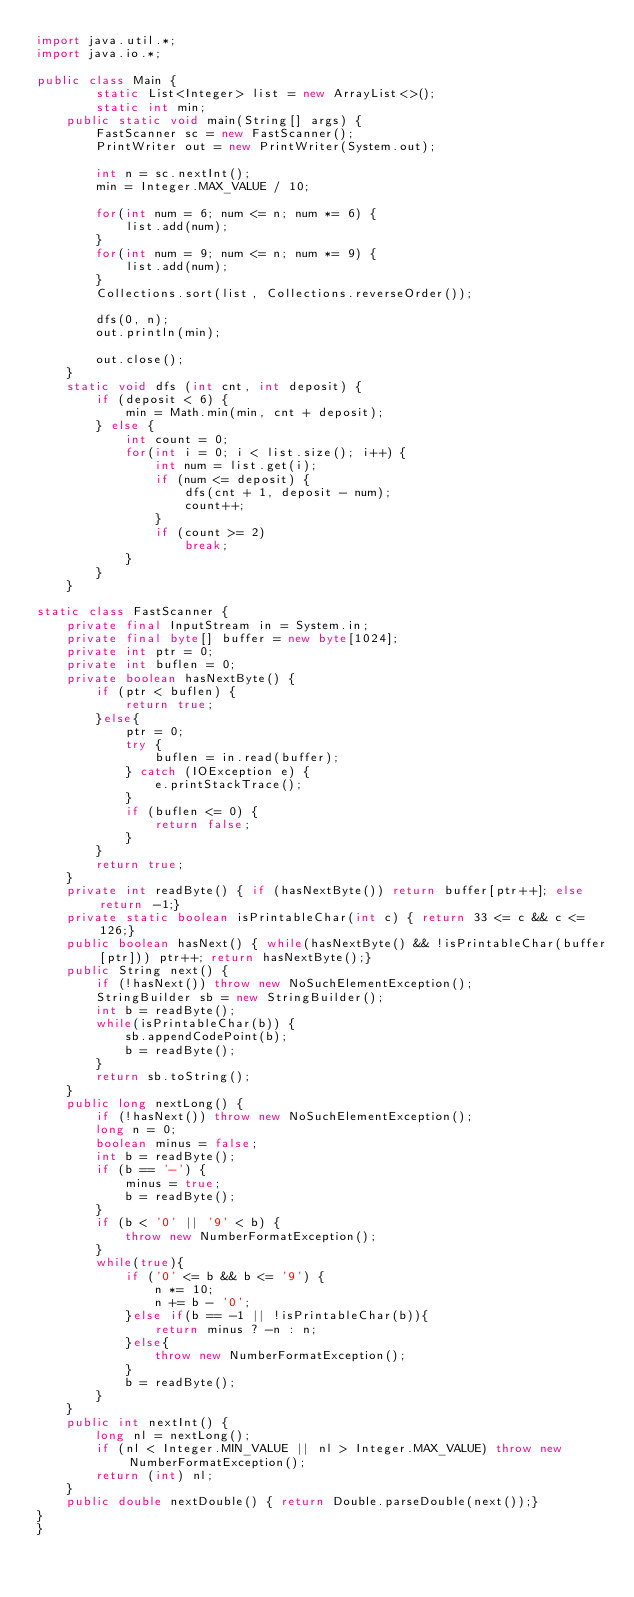<code> <loc_0><loc_0><loc_500><loc_500><_Java_>import java.util.*;
import java.io.*;

public class Main {
		static List<Integer> list = new ArrayList<>();
		static int min;
	public static void main(String[] args) {
		FastScanner sc = new FastScanner();
		PrintWriter out = new PrintWriter(System.out);
		
		int n = sc.nextInt();
		min = Integer.MAX_VALUE / 10;

		for(int num = 6; num <= n; num *= 6) {
			list.add(num);
		}
		for(int num = 9; num <= n; num *= 9) {
			list.add(num);
		}
		Collections.sort(list, Collections.reverseOrder());
		
		dfs(0, n);
		out.println(min);
				
		out.close();
	} 
	static void dfs (int cnt, int deposit) {
		if (deposit < 6) {
			min = Math.min(min, cnt + deposit);
		} else {
			int count = 0;
			for(int i = 0; i < list.size(); i++) {
				int num = list.get(i);
				if (num <= deposit) {
					dfs(cnt + 1, deposit - num);
					count++;
				}
				if (count >= 2)
					break;
			} 
		}
	}

static class FastScanner {
    private final InputStream in = System.in;
    private final byte[] buffer = new byte[1024];
    private int ptr = 0;
    private int buflen = 0;
    private boolean hasNextByte() {
        if (ptr < buflen) {
            return true;
        }else{
            ptr = 0;
            try {
                buflen = in.read(buffer);
            } catch (IOException e) {
                e.printStackTrace();
            }
            if (buflen <= 0) {
                return false;
            }
        }
        return true;
    }
    private int readByte() { if (hasNextByte()) return buffer[ptr++]; else return -1;}
    private static boolean isPrintableChar(int c) { return 33 <= c && c <= 126;}
    public boolean hasNext() { while(hasNextByte() && !isPrintableChar(buffer[ptr])) ptr++; return hasNextByte();}
    public String next() {
        if (!hasNext()) throw new NoSuchElementException();
        StringBuilder sb = new StringBuilder();
        int b = readByte();
        while(isPrintableChar(b)) {
            sb.appendCodePoint(b);
            b = readByte();
        }
        return sb.toString();
    }
    public long nextLong() {
        if (!hasNext()) throw new NoSuchElementException();
        long n = 0;
        boolean minus = false;
        int b = readByte();
        if (b == '-') {
            minus = true;
            b = readByte();
        }
        if (b < '0' || '9' < b) {
            throw new NumberFormatException();
        }
        while(true){
            if ('0' <= b && b <= '9') {
                n *= 10;
                n += b - '0';
            }else if(b == -1 || !isPrintableChar(b)){
                return minus ? -n : n;
            }else{
                throw new NumberFormatException();
            }
            b = readByte();
        }
    }
    public int nextInt() {
        long nl = nextLong();
        if (nl < Integer.MIN_VALUE || nl > Integer.MAX_VALUE) throw new NumberFormatException();
        return (int) nl;
    }
    public double nextDouble() { return Double.parseDouble(next());}
}
}
</code> 